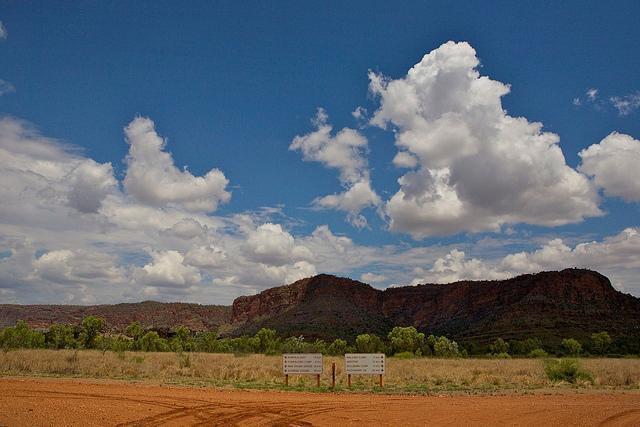How many signs are on the edge of the field?
Give a very brief answer. 2. 